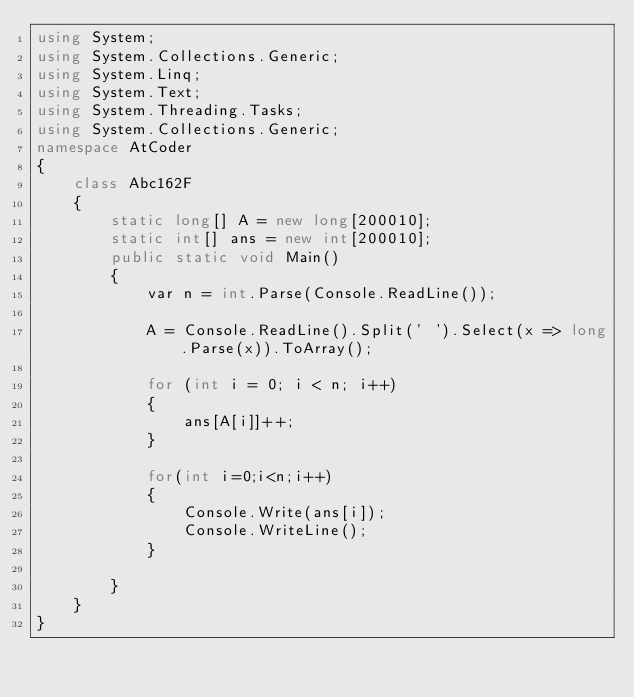<code> <loc_0><loc_0><loc_500><loc_500><_C#_>using System;
using System.Collections.Generic;
using System.Linq;
using System.Text;
using System.Threading.Tasks;
using System.Collections.Generic;
namespace AtCoder
{
    class Abc162F
    {
        static long[] A = new long[200010];
        static int[] ans = new int[200010];
        public static void Main()
        {
            var n = int.Parse(Console.ReadLine());

            A = Console.ReadLine().Split(' ').Select(x => long.Parse(x)).ToArray();

            for (int i = 0; i < n; i++)
            {
                ans[A[i]]++;
            }

            for(int i=0;i<n;i++)
            {
                Console.Write(ans[i]);
                Console.WriteLine();
            }

        }
    }
}
</code> 